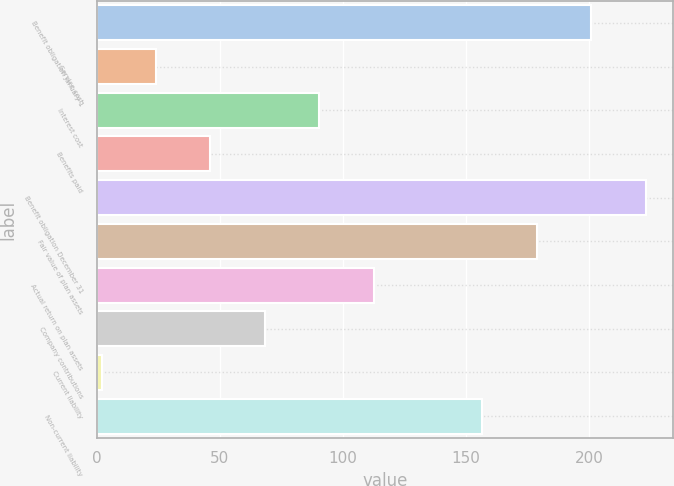<chart> <loc_0><loc_0><loc_500><loc_500><bar_chart><fcel>Benefit obligation January 1<fcel>Service cost<fcel>Interest cost<fcel>Benefits paid<fcel>Benefit obligation December 31<fcel>Fair value of plan assets<fcel>Actual return on plan assets<fcel>Company contributions<fcel>Current liability<fcel>Non-current liability<nl><fcel>200.9<fcel>24.1<fcel>90.4<fcel>46.2<fcel>223<fcel>178.8<fcel>112.5<fcel>68.3<fcel>2<fcel>156.7<nl></chart> 